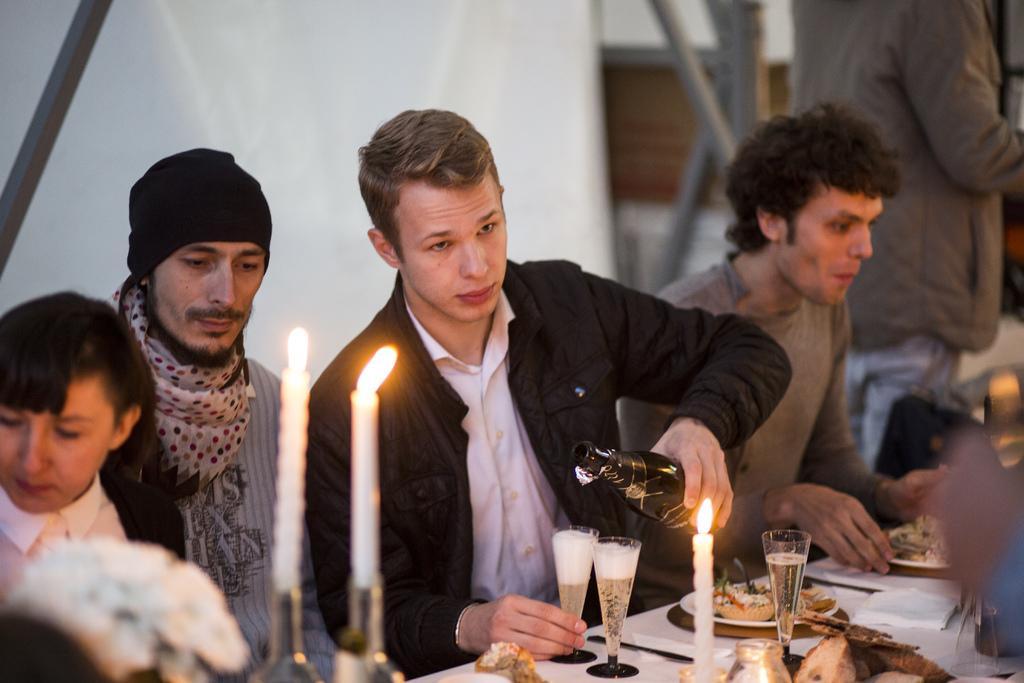In one or two sentences, can you explain what this image depicts? In the image we can see there are people standing and there are candles kept on the stand. There are wine glasses filled with wine and there are food items kept on the plate. There is a man holding wine bottle in his hand. 